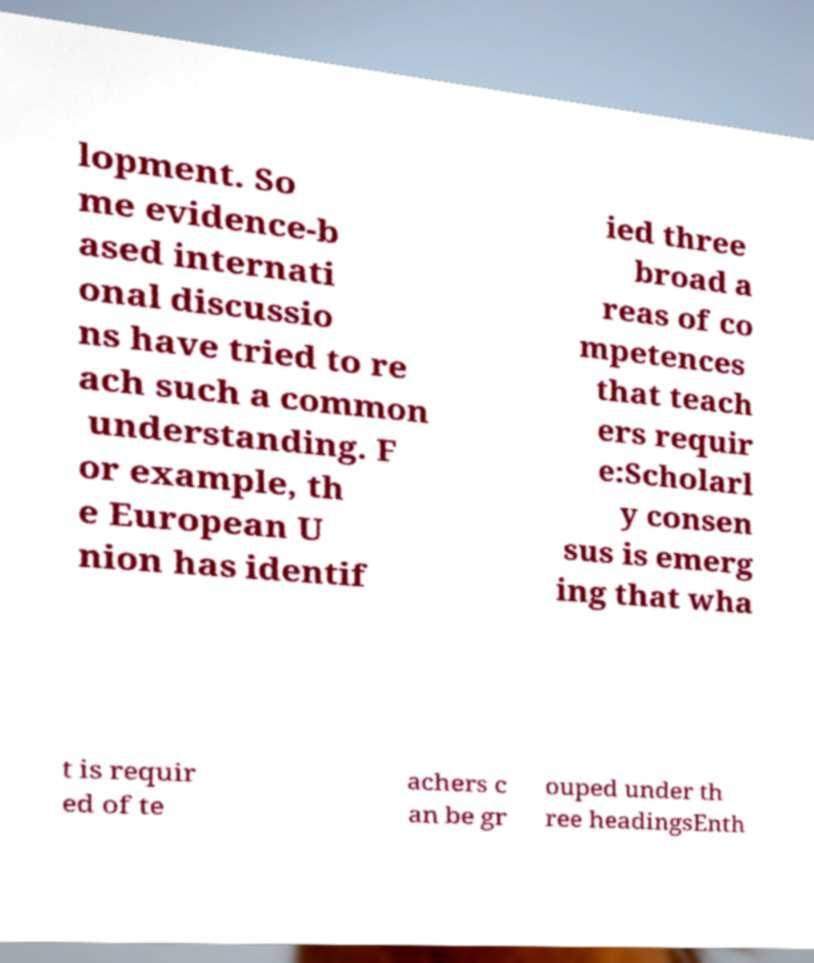Please identify and transcribe the text found in this image. lopment. So me evidence-b ased internati onal discussio ns have tried to re ach such a common understanding. F or example, th e European U nion has identif ied three broad a reas of co mpetences that teach ers requir e:Scholarl y consen sus is emerg ing that wha t is requir ed of te achers c an be gr ouped under th ree headingsEnth 